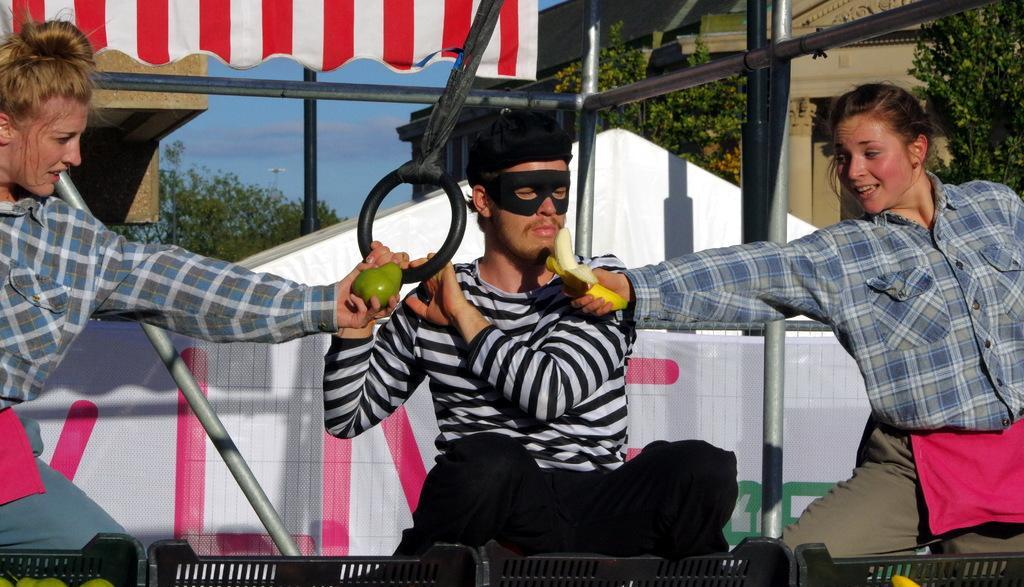How would you summarize this image in a sentence or two? In the foreground of this image, there is a man in the middle holding a circular ring like structure in his hands. At the bottom, there are few baskets. On either side to him, there are two women holding fruits in their hands. In the background, it seems like there is a tent, poles, buildings, trees and the sky. 